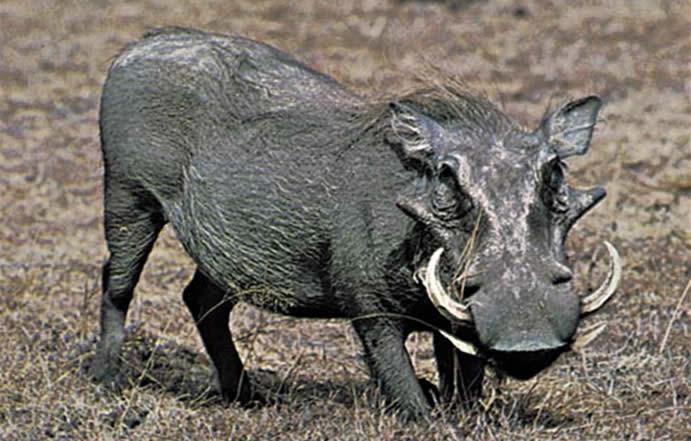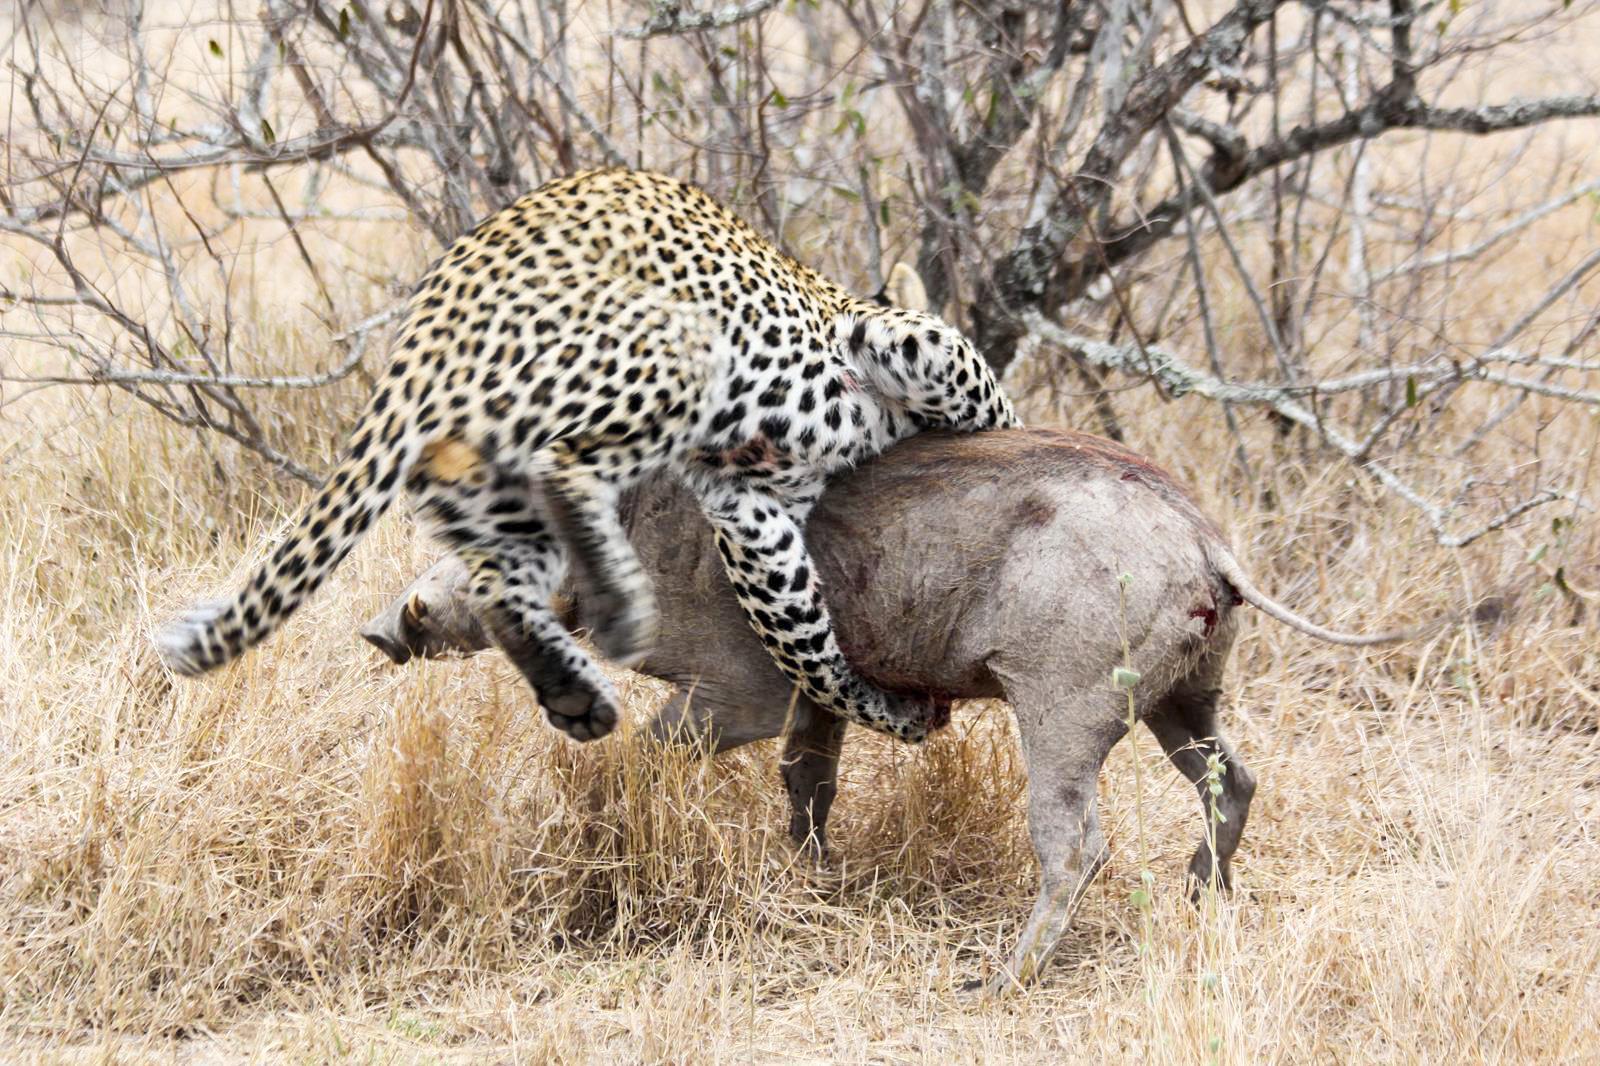The first image is the image on the left, the second image is the image on the right. Considering the images on both sides, is "Each image includes a warthog with its head facing the camera." valid? Answer yes or no. No. 